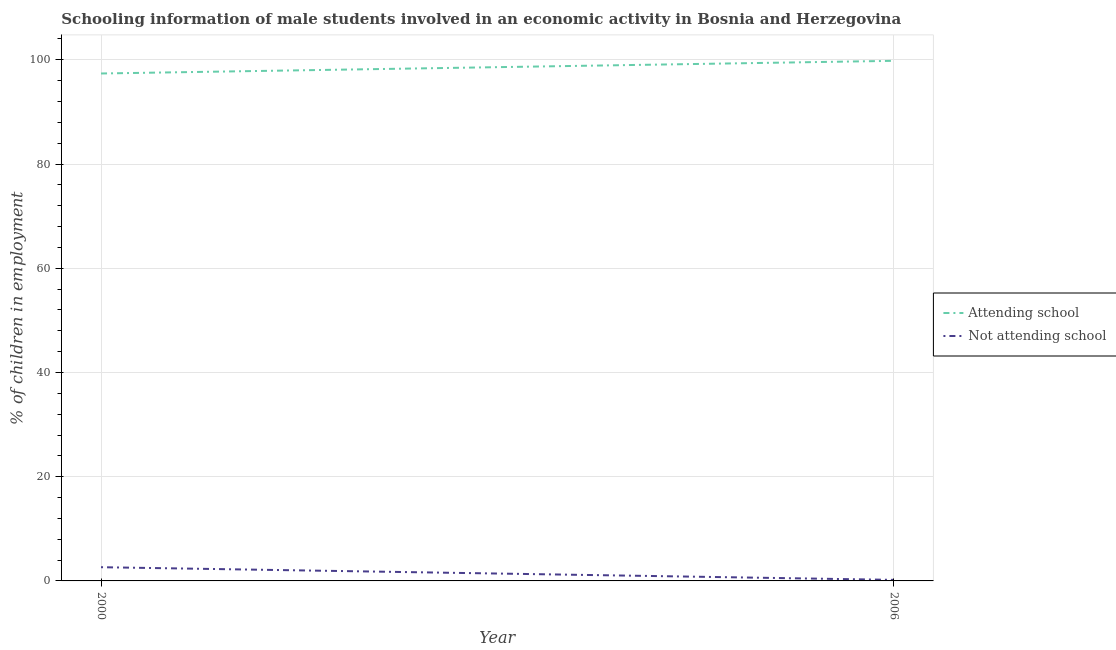Does the line corresponding to percentage of employed males who are attending school intersect with the line corresponding to percentage of employed males who are not attending school?
Your response must be concise. No. Is the number of lines equal to the number of legend labels?
Your answer should be compact. Yes. Across all years, what is the maximum percentage of employed males who are not attending school?
Your answer should be very brief. 2.63. Across all years, what is the minimum percentage of employed males who are not attending school?
Offer a terse response. 0.2. In which year was the percentage of employed males who are attending school maximum?
Provide a succinct answer. 2006. In which year was the percentage of employed males who are attending school minimum?
Give a very brief answer. 2000. What is the total percentage of employed males who are attending school in the graph?
Keep it short and to the point. 197.17. What is the difference between the percentage of employed males who are not attending school in 2000 and that in 2006?
Your answer should be very brief. 2.43. What is the difference between the percentage of employed males who are not attending school in 2006 and the percentage of employed males who are attending school in 2000?
Provide a short and direct response. -97.17. What is the average percentage of employed males who are not attending school per year?
Ensure brevity in your answer.  1.42. In the year 2006, what is the difference between the percentage of employed males who are not attending school and percentage of employed males who are attending school?
Provide a short and direct response. -99.6. What is the ratio of the percentage of employed males who are attending school in 2000 to that in 2006?
Keep it short and to the point. 0.98. In how many years, is the percentage of employed males who are not attending school greater than the average percentage of employed males who are not attending school taken over all years?
Provide a short and direct response. 1. Does the percentage of employed males who are not attending school monotonically increase over the years?
Keep it short and to the point. No. Is the percentage of employed males who are attending school strictly greater than the percentage of employed males who are not attending school over the years?
Offer a terse response. Yes. How many years are there in the graph?
Make the answer very short. 2. Are the values on the major ticks of Y-axis written in scientific E-notation?
Make the answer very short. No. Does the graph contain grids?
Your response must be concise. Yes. Where does the legend appear in the graph?
Offer a very short reply. Center right. How many legend labels are there?
Ensure brevity in your answer.  2. How are the legend labels stacked?
Ensure brevity in your answer.  Vertical. What is the title of the graph?
Provide a short and direct response. Schooling information of male students involved in an economic activity in Bosnia and Herzegovina. What is the label or title of the X-axis?
Provide a short and direct response. Year. What is the label or title of the Y-axis?
Give a very brief answer. % of children in employment. What is the % of children in employment of Attending school in 2000?
Provide a succinct answer. 97.37. What is the % of children in employment in Not attending school in 2000?
Your response must be concise. 2.63. What is the % of children in employment in Attending school in 2006?
Provide a succinct answer. 99.8. Across all years, what is the maximum % of children in employment in Attending school?
Make the answer very short. 99.8. Across all years, what is the maximum % of children in employment in Not attending school?
Make the answer very short. 2.63. Across all years, what is the minimum % of children in employment of Attending school?
Your answer should be very brief. 97.37. Across all years, what is the minimum % of children in employment of Not attending school?
Provide a succinct answer. 0.2. What is the total % of children in employment of Attending school in the graph?
Provide a short and direct response. 197.17. What is the total % of children in employment of Not attending school in the graph?
Ensure brevity in your answer.  2.83. What is the difference between the % of children in employment in Attending school in 2000 and that in 2006?
Your answer should be compact. -2.43. What is the difference between the % of children in employment of Not attending school in 2000 and that in 2006?
Give a very brief answer. 2.43. What is the difference between the % of children in employment of Attending school in 2000 and the % of children in employment of Not attending school in 2006?
Offer a very short reply. 97.17. What is the average % of children in employment in Attending school per year?
Make the answer very short. 98.58. What is the average % of children in employment of Not attending school per year?
Make the answer very short. 1.42. In the year 2000, what is the difference between the % of children in employment in Attending school and % of children in employment in Not attending school?
Offer a terse response. 94.74. In the year 2006, what is the difference between the % of children in employment in Attending school and % of children in employment in Not attending school?
Give a very brief answer. 99.6. What is the ratio of the % of children in employment in Attending school in 2000 to that in 2006?
Your answer should be compact. 0.98. What is the ratio of the % of children in employment of Not attending school in 2000 to that in 2006?
Your answer should be very brief. 13.16. What is the difference between the highest and the second highest % of children in employment in Attending school?
Keep it short and to the point. 2.43. What is the difference between the highest and the second highest % of children in employment of Not attending school?
Your answer should be compact. 2.43. What is the difference between the highest and the lowest % of children in employment of Attending school?
Your answer should be compact. 2.43. What is the difference between the highest and the lowest % of children in employment of Not attending school?
Give a very brief answer. 2.43. 